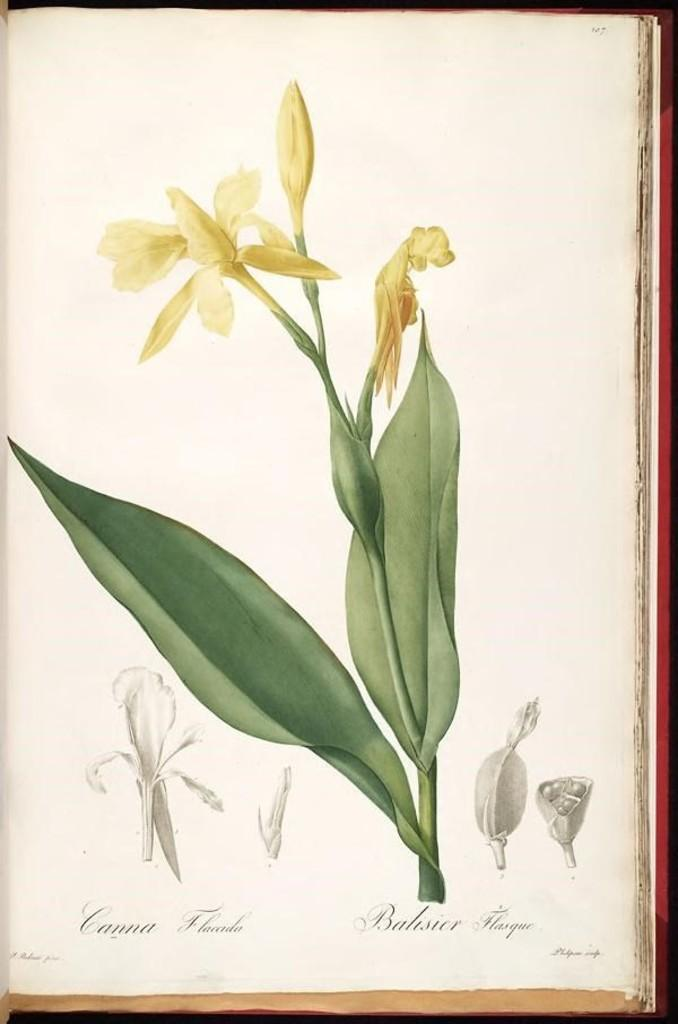What is present in the image that contains visuals and text? There is a poster in the image that contains images and text. Can you describe the images on the poster? The provided facts do not give any details about the images on the poster, so we cannot describe them. What type of information is conveyed through the text on the poster? The provided facts do not give any details about the text on the poster, so we cannot describe the information conveyed. How does the can on the poster contribute to the overall message? There is no can present on the poster, as the provided facts only mention images and text. 